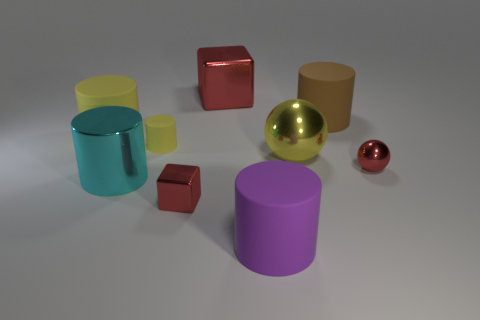Subtract all purple cylinders. How many cylinders are left? 4 Subtract all cyan cylinders. How many cylinders are left? 4 Subtract all gray cylinders. Subtract all red blocks. How many cylinders are left? 5 Add 1 big blue matte cubes. How many objects exist? 10 Subtract all cylinders. How many objects are left? 4 Add 1 large metallic things. How many large metallic things exist? 4 Subtract 0 yellow blocks. How many objects are left? 9 Subtract all big brown rubber cylinders. Subtract all big cyan things. How many objects are left? 7 Add 3 big red objects. How many big red objects are left? 4 